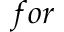<formula> <loc_0><loc_0><loc_500><loc_500>f o r</formula> 